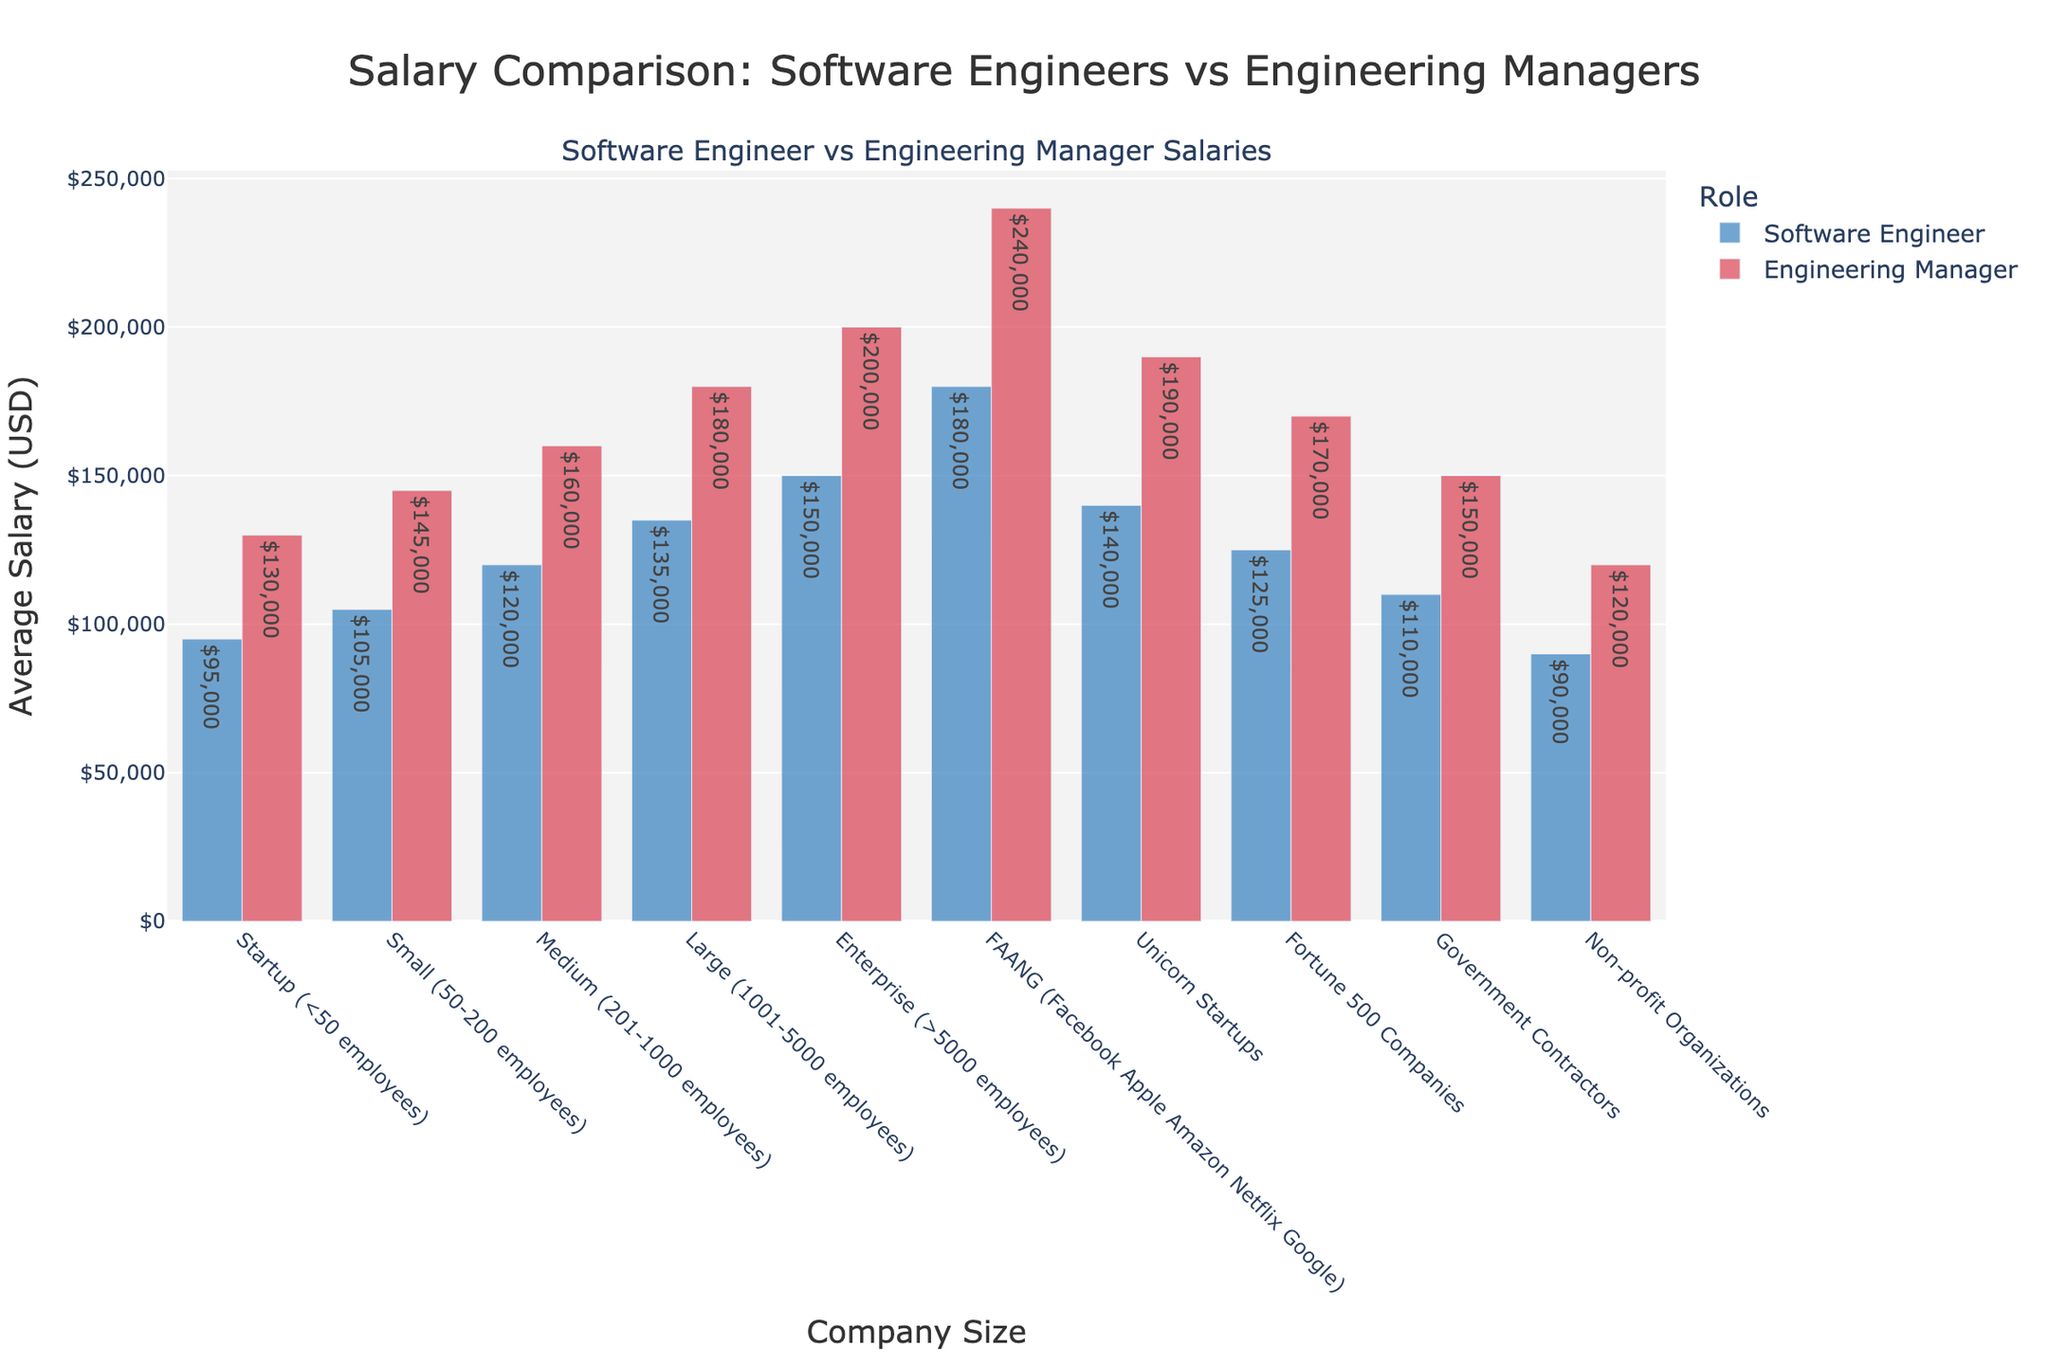Which company size has the highest average salary for both software engineers and engineering managers? The highest average salaries for both roles are in FAANG companies. These values are represented by the tallest bars in the respective categories with $180,000 for software engineers and $240,000 for engineering managers.
Answer: FAANG companies What is the difference in salary between software engineers and engineering managers in medium-sized companies? The average salary for a software engineer in medium-sized companies (201-1000 employees) is $120,000, and for an engineering manager, it is $160,000. The difference is calculated as $160,000 - $120,000.
Answer: $40,000 Which company size shows the smallest gap between software engineers and engineering managers' salaries? By analyzing the height difference of the bars across different company sizes, non-profit organizations have the smallest gap. The salaries are $90,000 for software engineers and $120,000 for engineering managers, resulting in a gap of $30,000.
Answer: Non-profit organizations How have salaries for software engineers and engineering managers changed from startup to enterprise companies? Compare the overall trend. Software engineer salaries increase from $95,000 in startups to $150,000 in enterprise companies, showing a consistent upward trend. For engineering managers, the salaries increase from $130,000 in startups to $200,000 in enterprise companies, also showing a consistent rise.
Answer: Consistent upward trend for both What is the first company size category where engineering manager salaries exceed $150,000? The first company size where engineering manager salaries exceed $150,000 is medium-sized companies (201-1000 employees), where the salary is $160,000.
Answer: Medium (201-1000 employees) Calculate the total combined average salary (for both roles) in large companies. The average salary for software engineers in large companies is $135,000 and for engineering managers, it is $180,000. Sum these values to get the total combined average salary: $135,000 + $180,000.
Answer: $315,000 Which segment has a larger salary difference between the roles, Unicorn Startups or Fortune 500 Companies? For Unicorn Startups, the salary difference between software engineers and engineering managers is $190,000 - $140,000 = $50,000. For Fortune 500 companies, the difference is $170,000 - $125,000 = $45,000. Thus, Unicorn Startups have a larger difference.
Answer: Unicorn Startups In which company size category do software engineers earn six-figure salaries starting from? Software engineers start earning six-figure salaries from small companies (50-200 employees) onward, where the average salary is $105,000.
Answer: Small companies (50-200 employees) For government contractors, what is the percentage increase in salary from a software engineer to an engineering manager? The salary of a software engineer for government contractors is $110,000, and for an engineering manager, it is $150,000. The percentage increase is calculated as: (($150,000 - $110,000) / $110,000) * 100.
Answer: 36.36% Compare the average software engineer salaries in startups and FAANG companies. How much higher is the salary in FAANG companies? The average salary for software engineers in startups is $95,000, and in FAANG companies, it is $180,000. The difference is $180,000 - $95,000.
Answer: $85,000 